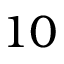<formula> <loc_0><loc_0><loc_500><loc_500>1 0</formula> 